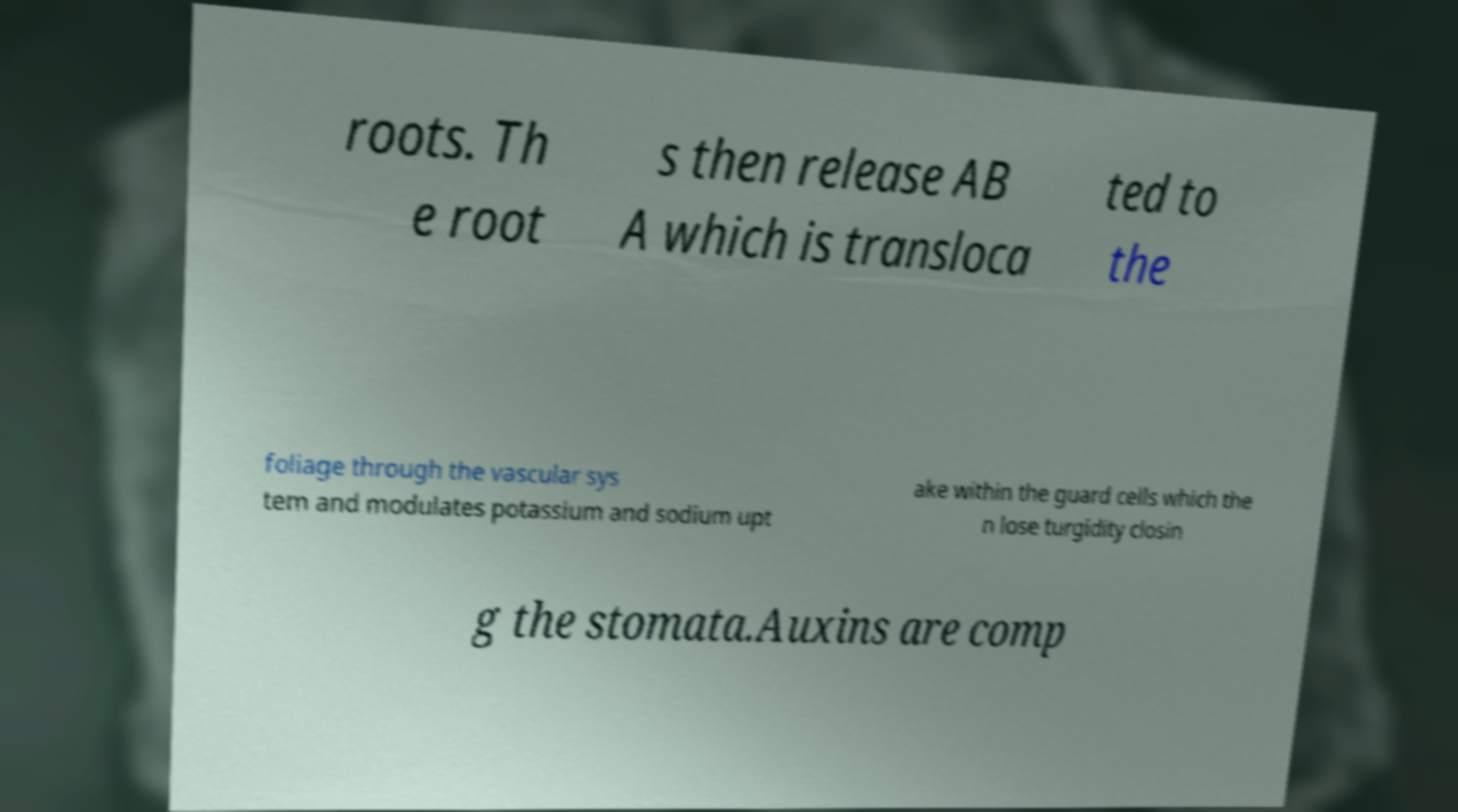Can you read and provide the text displayed in the image?This photo seems to have some interesting text. Can you extract and type it out for me? roots. Th e root s then release AB A which is transloca ted to the foliage through the vascular sys tem and modulates potassium and sodium upt ake within the guard cells which the n lose turgidity closin g the stomata.Auxins are comp 